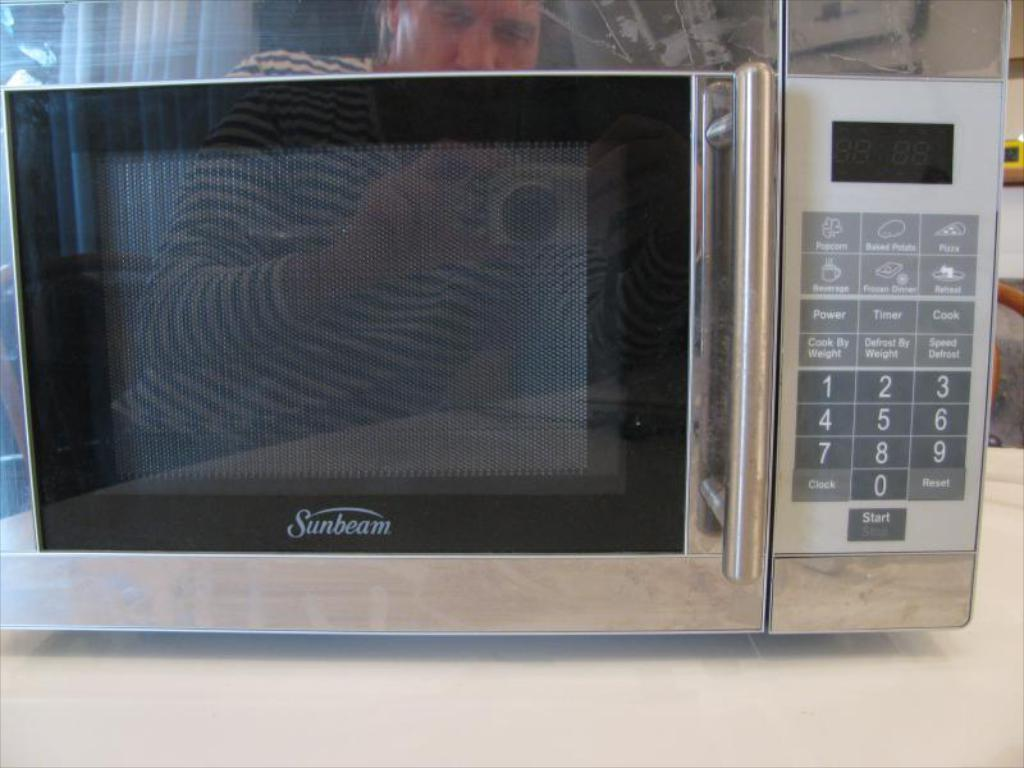<image>
Write a terse but informative summary of the picture. A Sunbeam brand microwave is being photographed by a person. 